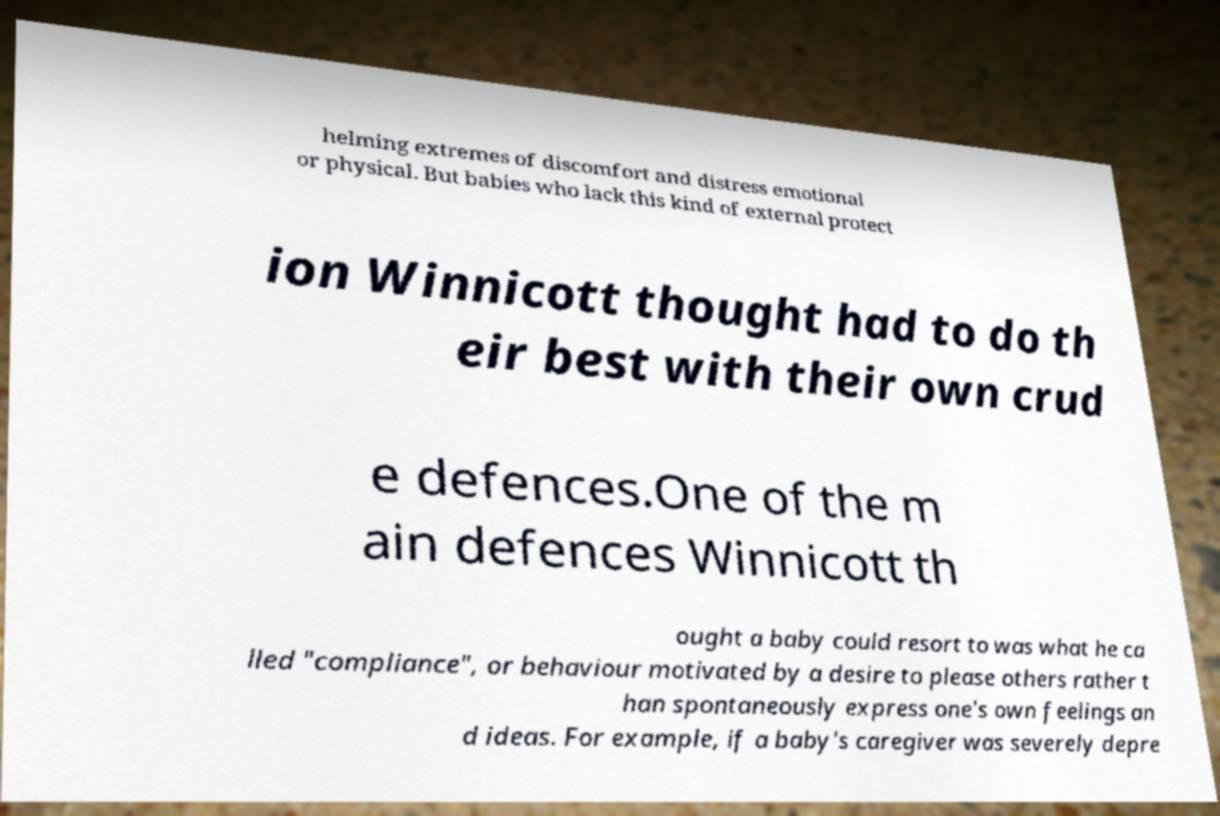Can you accurately transcribe the text from the provided image for me? helming extremes of discomfort and distress emotional or physical. But babies who lack this kind of external protect ion Winnicott thought had to do th eir best with their own crud e defences.One of the m ain defences Winnicott th ought a baby could resort to was what he ca lled "compliance", or behaviour motivated by a desire to please others rather t han spontaneously express one's own feelings an d ideas. For example, if a baby's caregiver was severely depre 